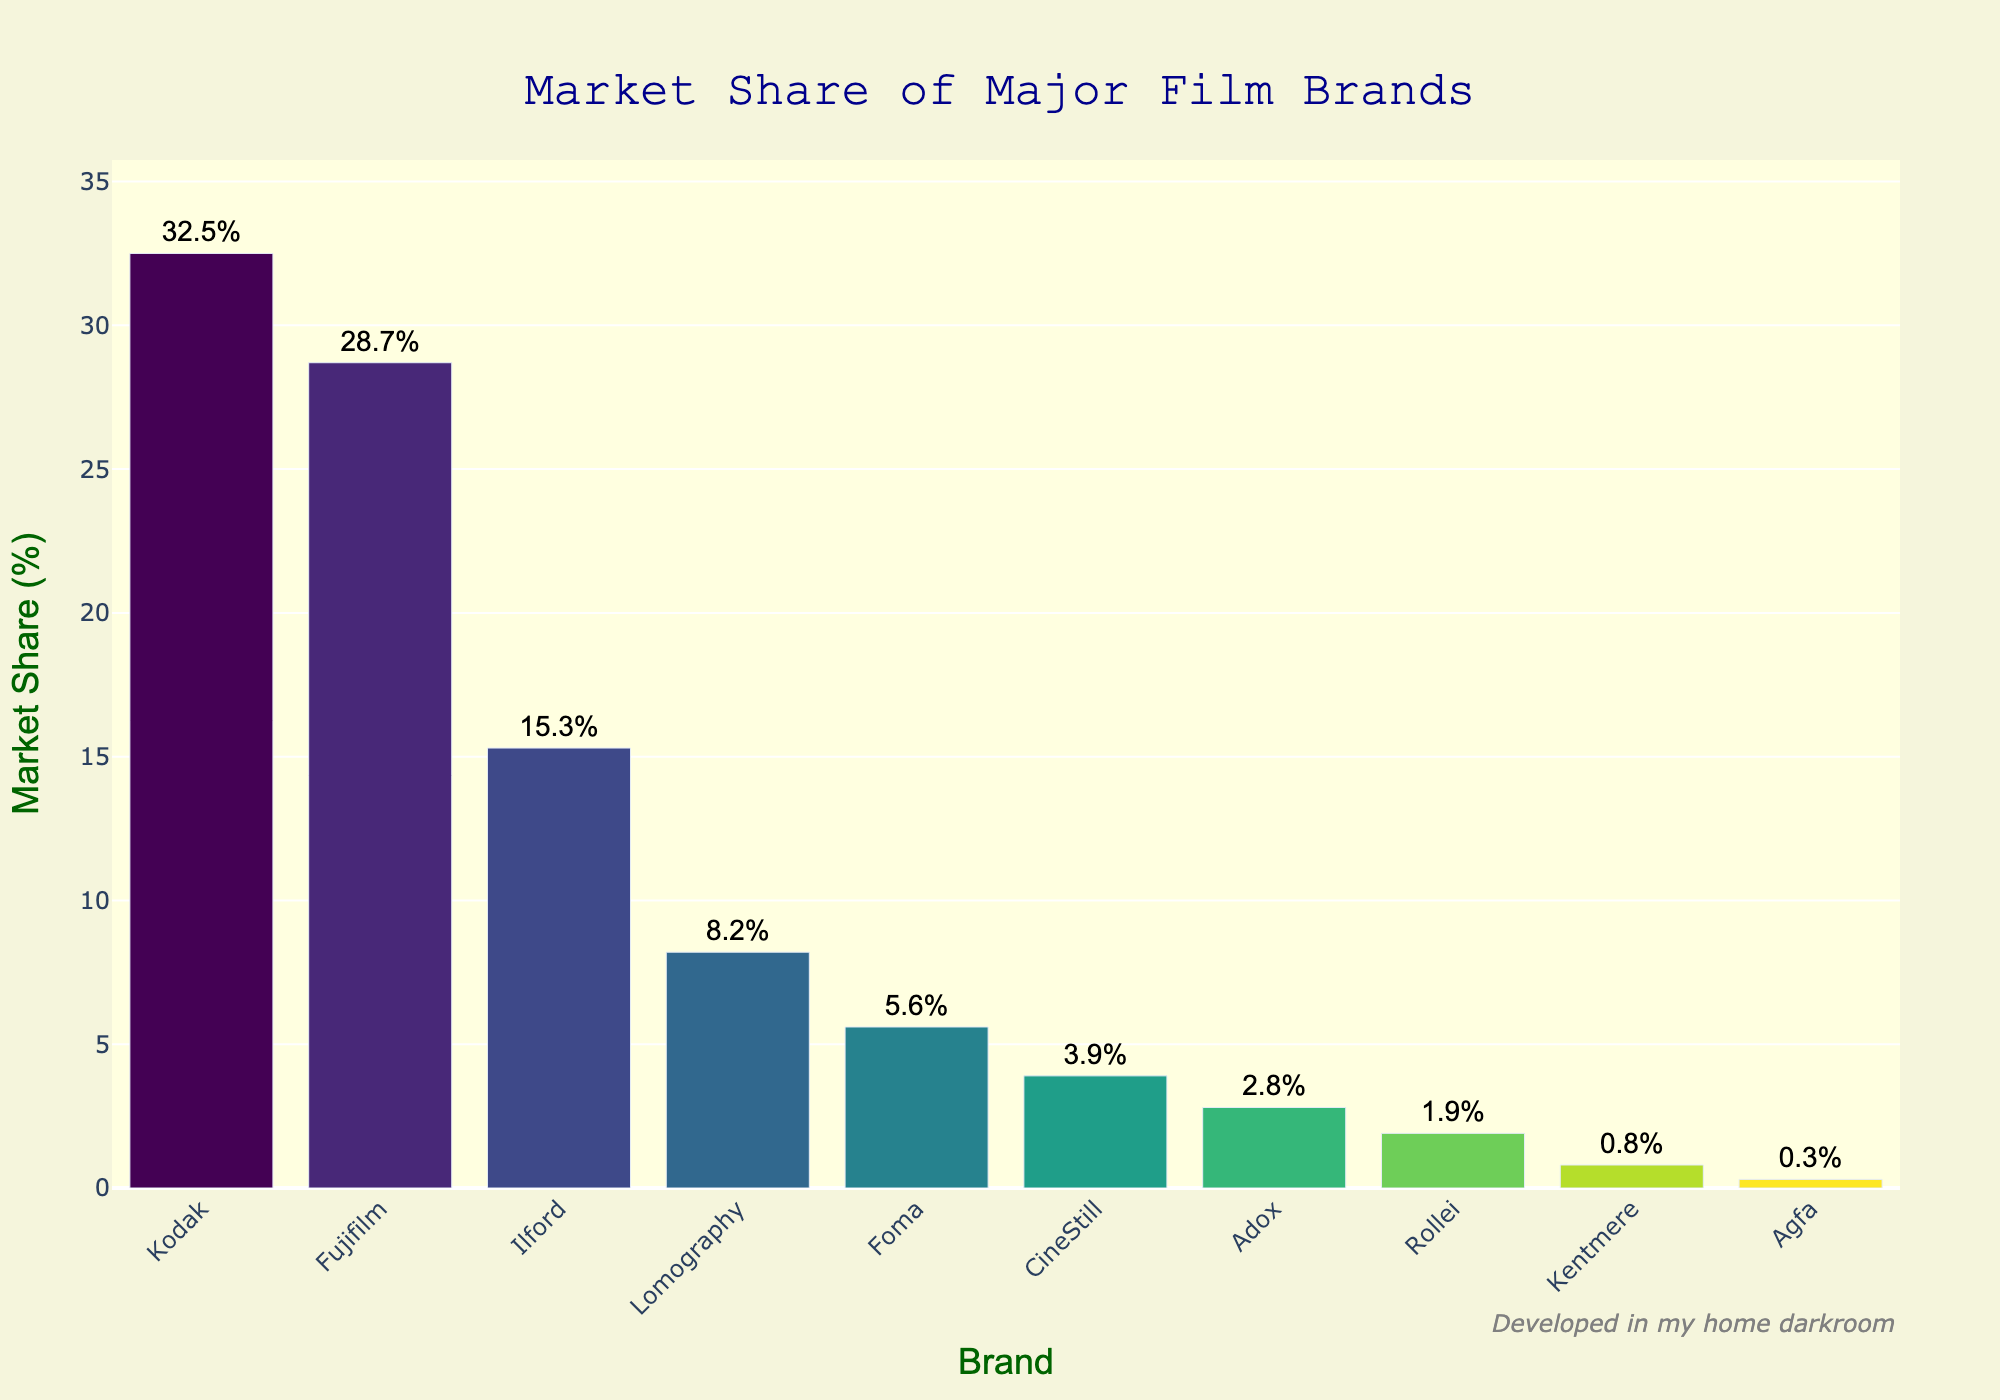what is the market share difference between Kodak and Fujifilm? The market share of Kodak is 32.5%, and the market share of Fujifilm is 28.7%. Subtracting these gives 32.5% - 28.7% = 3.8%
Answer: 3.8% What is the combined market share of Ilford, Lomography, and Foma? Adding the market shares of Ilford (15.3%), Lomography (8.2%), and Foma (5.6%) gives 15.3% + 8.2% + 5.6% = 29.1%
Answer: 29.1% Which brand holds the smallest market share? Looking at the bar chart, Agfa has the smallest bar with a market share of 0.3%
Answer: Agfa How much larger is the market share of Kodak compared to Ilford? The market share of Kodak is 32.5%, the market share of Ilford is 15.3%. Subtracting these gives 32.5% - 15.3%: 17.2%
Answer: 17.2% Between Lomography and CineStill, which has a greater market share, and by how much? Lomography has a market share of 8.2%, while CineStill has 3.9%. The difference is 8.2% - 3.9% = 4.3%
Answer: Lomography, 4.3% What is the sum of the market shares of brands with less than 5% market share? The brands with less than 5% market share are CineStill (3.9%), Adox (2.8%), Rollei (1.9%), Kentmere (0.8%), and Agfa (0.3%). Summing these gives 3.9% + 2.8% + 1.9% + 0.8% + 0.3% = 9.7%
Answer: 9.7% What is the average market share of the brands listed? Adding all the market shares and dividing by the number of brands (10) gives: (32.5% + 28.7% + 15.3% + 8.2% + 5.6% + 3.9% + 2.8% + 1.9% + 0.8% + 0.3%) / 10 = 100% / 10 = 10%
Answer: 10% Which brand has the tallest bar on the chart? The tallest bar is for Kodak, indicating it has the highest market share of 32.5%
Answer: Kodak If the combined market share of Kodak and Fujifilm is considered, what percentage of the total market does this represent? The combined market share of Kodak (32.5%) and Fujifilm (28.7%) is: 32.5% + 28.7% = 61.2%
Answer: 61.2% Which brands have a market share below the average market share, and what are their shares? The average market share is 10%. Brands below the average are Lomography (8.2%), Foma (5.6%), CineStill (3.9%), Adox (2.8%), Rollei (1.9%), Kentmere (0.8%), and Agfa (0.3%)
Answer: Lomography: 8.2%, Foma: 5.6%, CineStill: 3.9%, Adox: 2.8%, Rollei: 1.9%, Kentmere: 0.8%, Agfa: 0.3% 